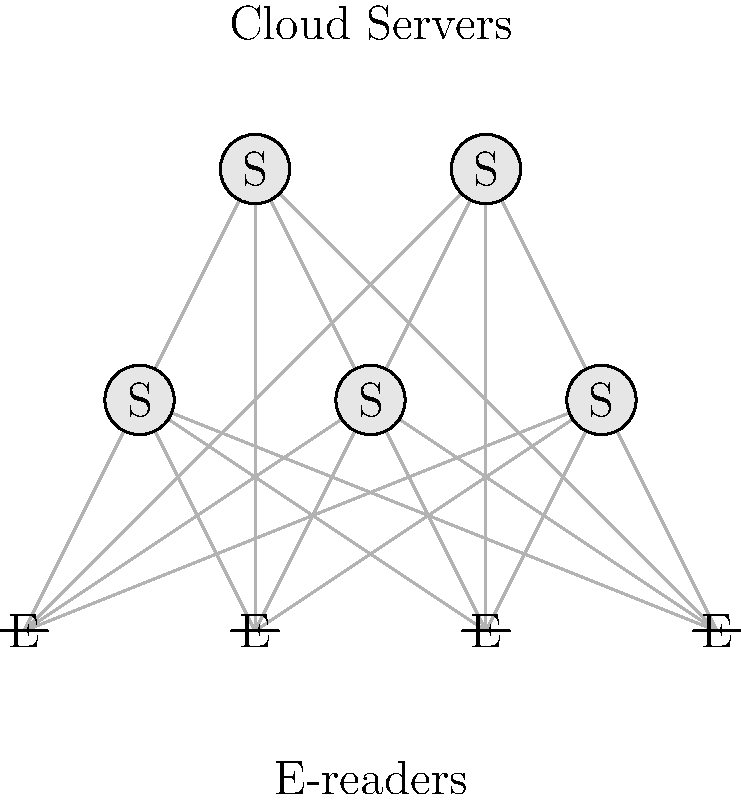Based on the network topology shown in the diagram, which type of network architecture best describes the e-reader's syncing system with cloud servers? To determine the network architecture of the e-reader's syncing system, let's analyze the diagram step-by-step:

1. Observe the components:
   - There are multiple cloud servers (labeled "S") at the top.
   - There are multiple e-readers (labeled "E") at the bottom.

2. Examine the connections:
   - Each e-reader is connected to every cloud server.
   - There are no direct connections between e-readers.
   - There are no direct connections between cloud servers.

3. Analyze the structure:
   - The connections form a bipartite graph, with two distinct sets of nodes (servers and e-readers).
   - Every node in one set (e-readers) is connected to every node in the other set (servers).

4. Consider the characteristics:
   - This topology allows each e-reader to communicate with any server.
   - It provides redundancy and load balancing capabilities.
   - There's no central point of failure, as multiple servers are available.

5. Identify the architecture:
   - This structure is characteristic of a mesh topology, specifically a partial mesh.
   - In a full mesh, every node would be connected to every other node, which is not the case here.
   - The partial mesh is limited to connections between the two distinct sets (servers and e-readers).

Given these observations, the network architecture that best describes this e-reader's syncing system is a partial mesh topology. This allows for efficient synchronization, redundancy, and scalability in the e-reader cloud syncing ecosystem.
Answer: Partial mesh topology 